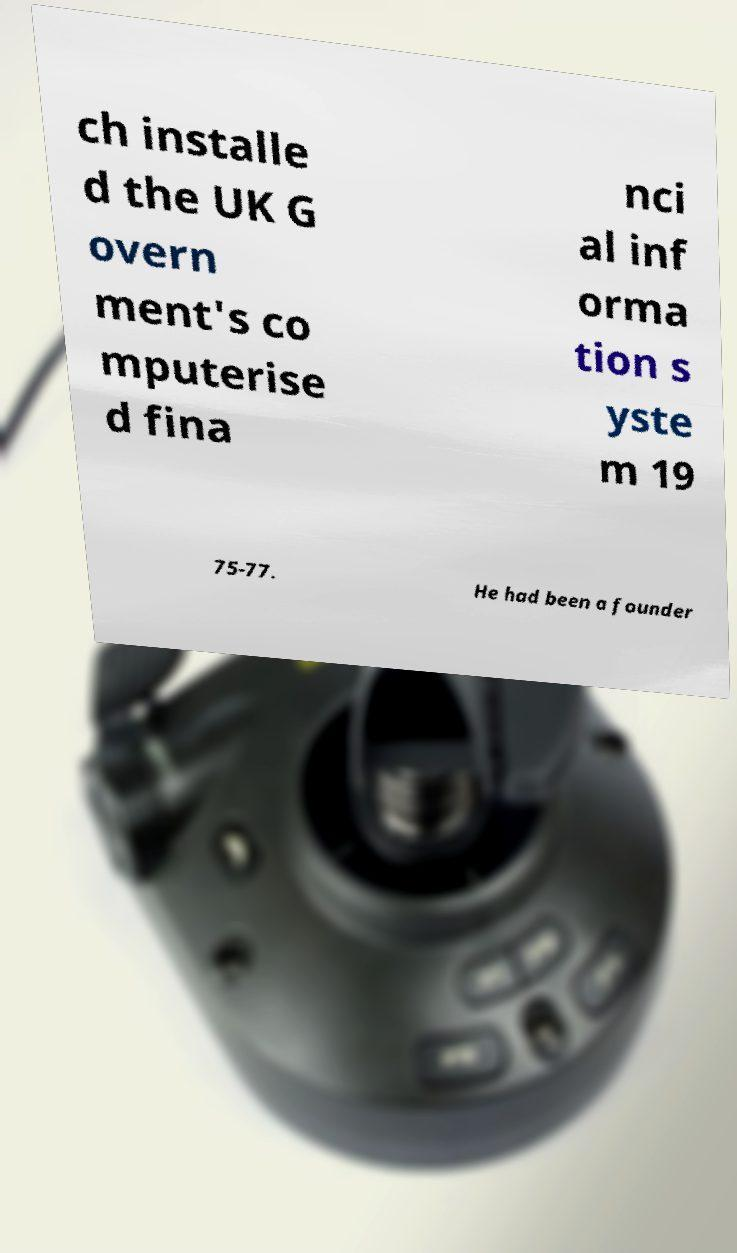Can you read and provide the text displayed in the image?This photo seems to have some interesting text. Can you extract and type it out for me? ch installe d the UK G overn ment's co mputerise d fina nci al inf orma tion s yste m 19 75-77. He had been a founder 